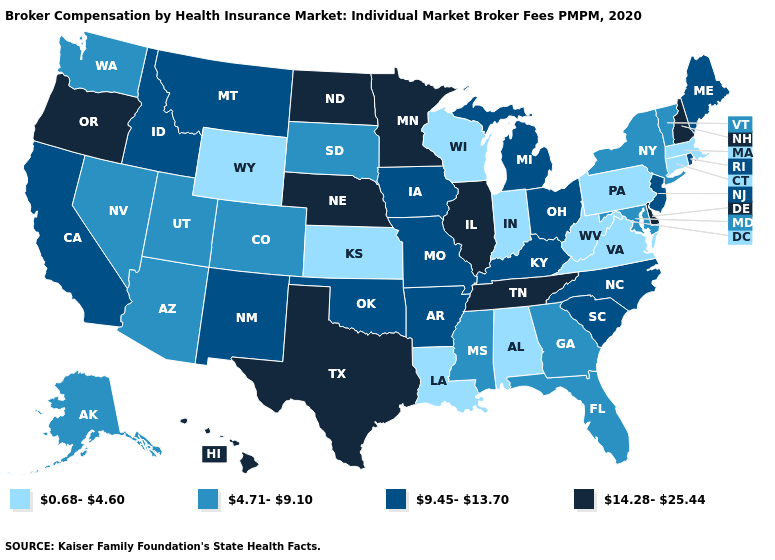Among the states that border Delaware , does Pennsylvania have the lowest value?
Give a very brief answer. Yes. Does Louisiana have the lowest value in the South?
Be succinct. Yes. What is the value of Nebraska?
Concise answer only. 14.28-25.44. Does Wyoming have the lowest value in the USA?
Give a very brief answer. Yes. Which states have the lowest value in the USA?
Be succinct. Alabama, Connecticut, Indiana, Kansas, Louisiana, Massachusetts, Pennsylvania, Virginia, West Virginia, Wisconsin, Wyoming. Among the states that border Iowa , does Minnesota have the highest value?
Keep it brief. Yes. Name the states that have a value in the range 9.45-13.70?
Short answer required. Arkansas, California, Idaho, Iowa, Kentucky, Maine, Michigan, Missouri, Montana, New Jersey, New Mexico, North Carolina, Ohio, Oklahoma, Rhode Island, South Carolina. Name the states that have a value in the range 14.28-25.44?
Concise answer only. Delaware, Hawaii, Illinois, Minnesota, Nebraska, New Hampshire, North Dakota, Oregon, Tennessee, Texas. Which states hav the highest value in the West?
Give a very brief answer. Hawaii, Oregon. How many symbols are there in the legend?
Concise answer only. 4. Which states have the lowest value in the MidWest?
Concise answer only. Indiana, Kansas, Wisconsin. What is the lowest value in states that border New Mexico?
Answer briefly. 4.71-9.10. Name the states that have a value in the range 0.68-4.60?
Write a very short answer. Alabama, Connecticut, Indiana, Kansas, Louisiana, Massachusetts, Pennsylvania, Virginia, West Virginia, Wisconsin, Wyoming. Name the states that have a value in the range 14.28-25.44?
Quick response, please. Delaware, Hawaii, Illinois, Minnesota, Nebraska, New Hampshire, North Dakota, Oregon, Tennessee, Texas. What is the highest value in the Northeast ?
Quick response, please. 14.28-25.44. 